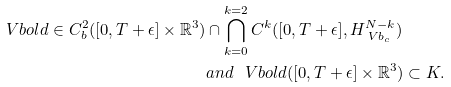Convert formula to latex. <formula><loc_0><loc_0><loc_500><loc_500>\ V b o l d \in C _ { b } ^ { 2 } ( [ 0 , T + \epsilon ] \times \mathbb { R } ^ { 3 } ) & \cap \bigcap _ { k = 0 } ^ { k = 2 } C ^ { k } ( [ 0 , T + \epsilon ] , H _ { \ V b _ { c } } ^ { N - k } ) \\ & a n d \ \ \ V b o l d ( [ 0 , T + \epsilon ] \times \mathbb { R } ^ { 3 } ) \subset K .</formula> 